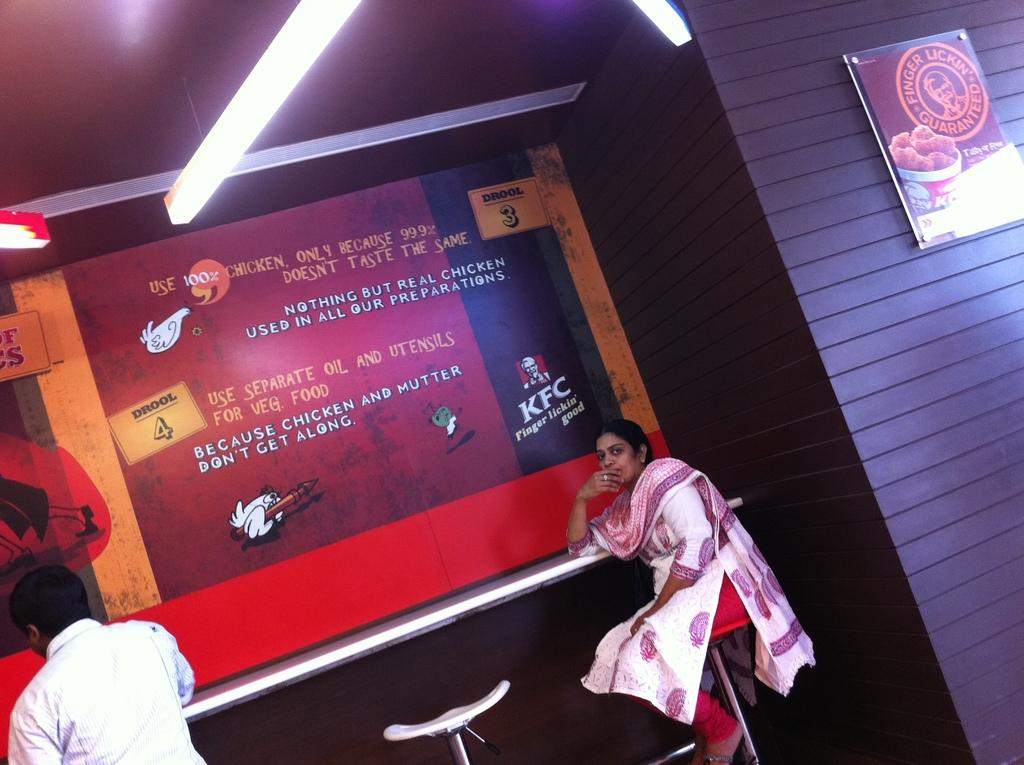Provide a one-sentence caption for the provided image. A woman and a man at a table under a KFC sign. 